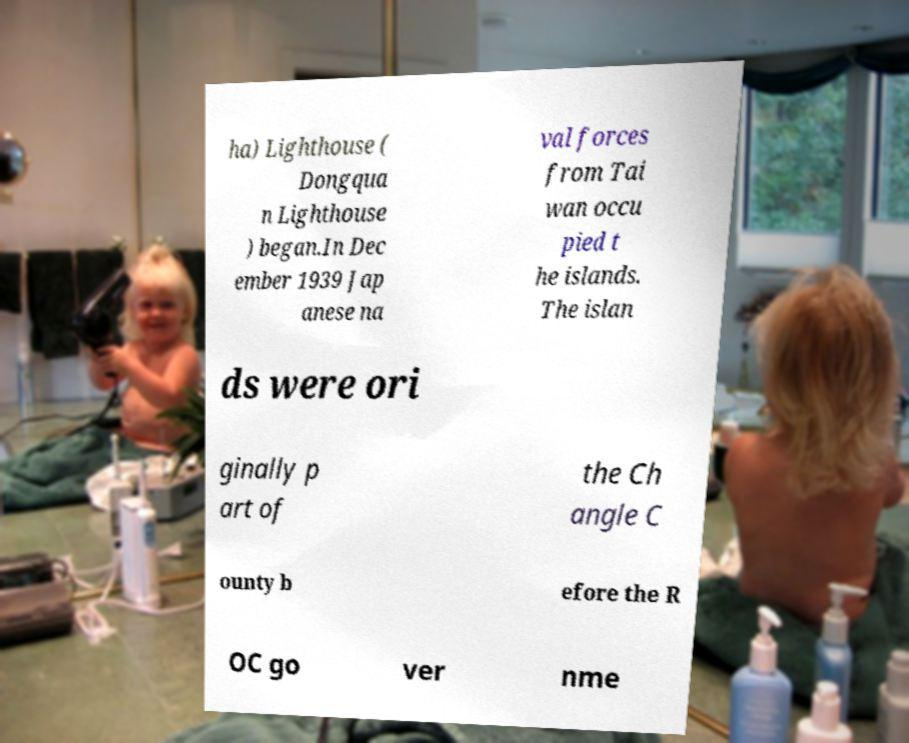Can you accurately transcribe the text from the provided image for me? ha) Lighthouse ( Dongqua n Lighthouse ) began.In Dec ember 1939 Jap anese na val forces from Tai wan occu pied t he islands. The islan ds were ori ginally p art of the Ch angle C ounty b efore the R OC go ver nme 